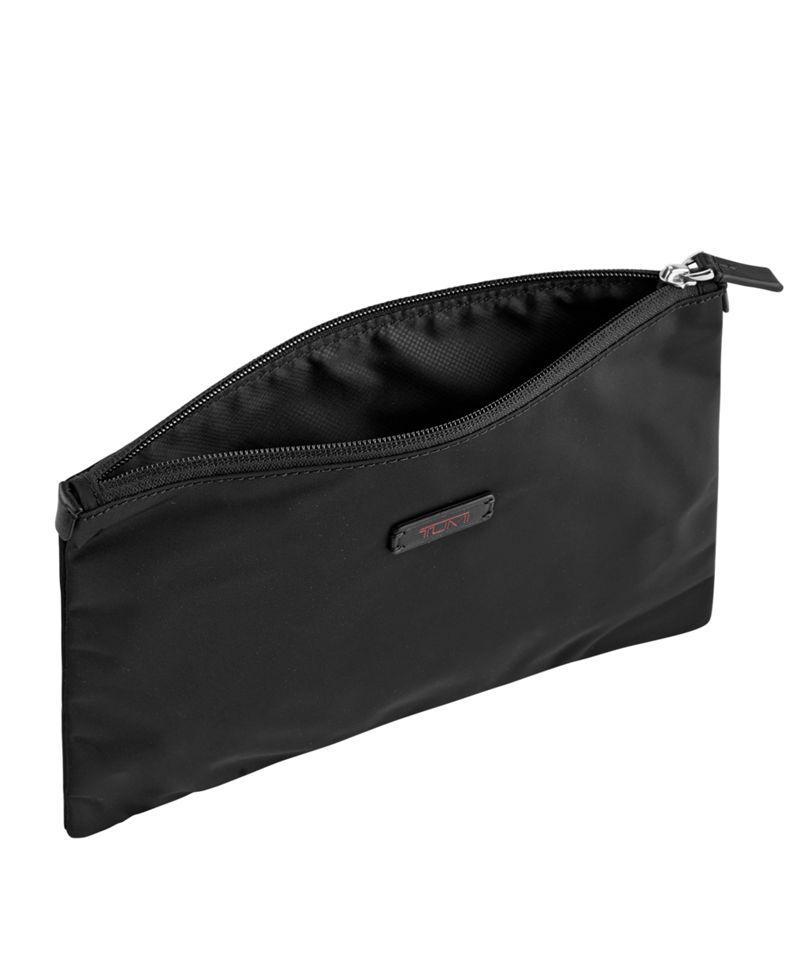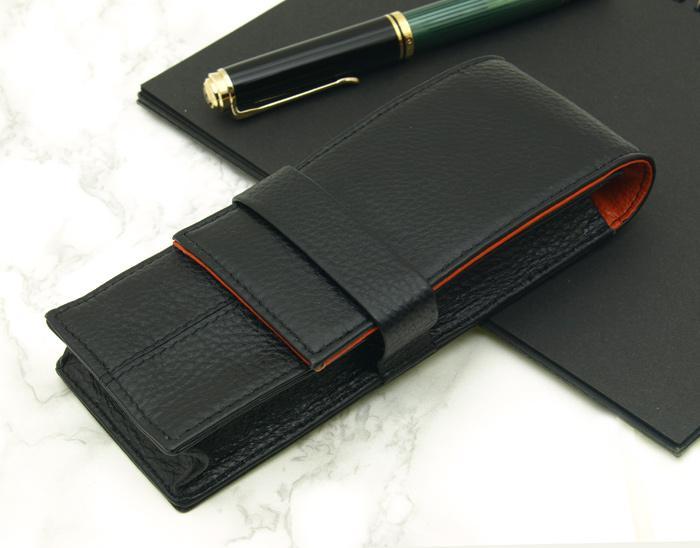The first image is the image on the left, the second image is the image on the right. Evaluate the accuracy of this statement regarding the images: "The container in the image on the left is open.". Is it true? Answer yes or no. Yes. 